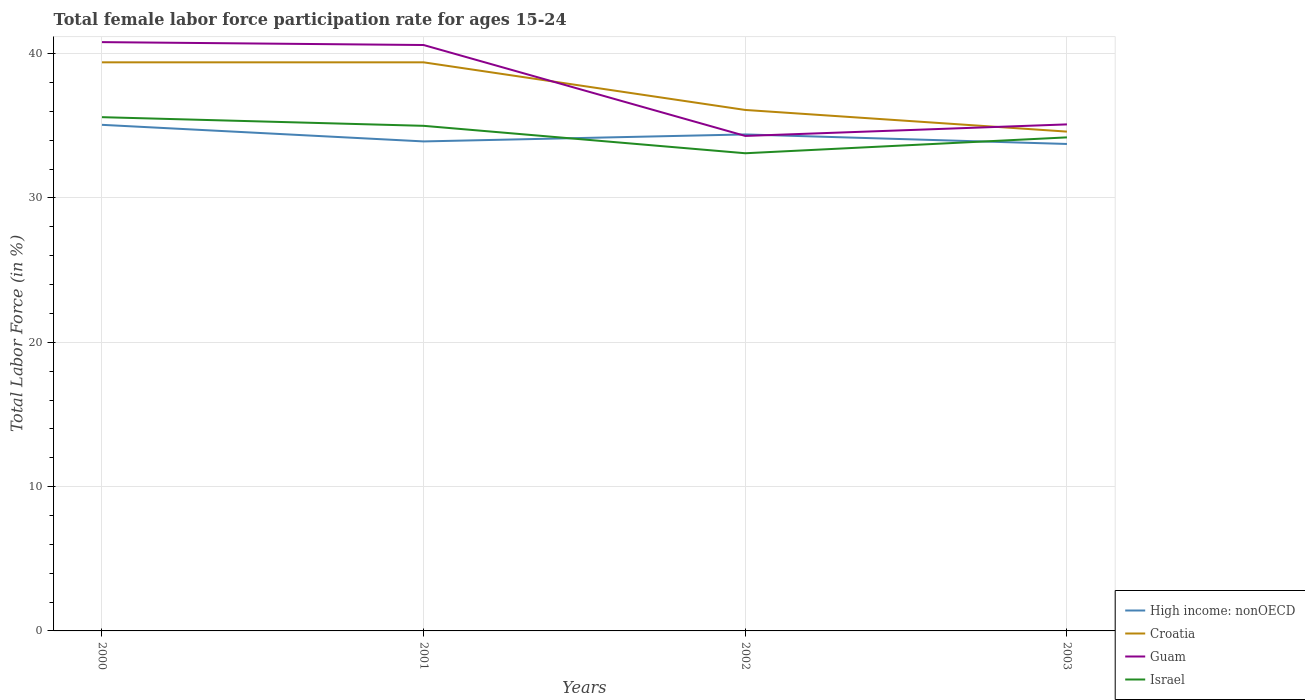How many different coloured lines are there?
Your answer should be compact. 4. Does the line corresponding to Guam intersect with the line corresponding to High income: nonOECD?
Your answer should be compact. Yes. Across all years, what is the maximum female labor force participation rate in Guam?
Your response must be concise. 34.3. In which year was the female labor force participation rate in Israel maximum?
Provide a short and direct response. 2002. What is the difference between the highest and the second highest female labor force participation rate in Croatia?
Your response must be concise. 4.8. What is the difference between the highest and the lowest female labor force participation rate in Croatia?
Your answer should be compact. 2. Are the values on the major ticks of Y-axis written in scientific E-notation?
Offer a terse response. No. Where does the legend appear in the graph?
Ensure brevity in your answer.  Bottom right. What is the title of the graph?
Offer a terse response. Total female labor force participation rate for ages 15-24. What is the Total Labor Force (in %) in High income: nonOECD in 2000?
Your response must be concise. 35.07. What is the Total Labor Force (in %) of Croatia in 2000?
Your answer should be compact. 39.4. What is the Total Labor Force (in %) of Guam in 2000?
Provide a succinct answer. 40.8. What is the Total Labor Force (in %) of Israel in 2000?
Keep it short and to the point. 35.6. What is the Total Labor Force (in %) of High income: nonOECD in 2001?
Provide a succinct answer. 33.92. What is the Total Labor Force (in %) of Croatia in 2001?
Keep it short and to the point. 39.4. What is the Total Labor Force (in %) in Guam in 2001?
Give a very brief answer. 40.6. What is the Total Labor Force (in %) in High income: nonOECD in 2002?
Your response must be concise. 34.4. What is the Total Labor Force (in %) in Croatia in 2002?
Make the answer very short. 36.1. What is the Total Labor Force (in %) in Guam in 2002?
Provide a short and direct response. 34.3. What is the Total Labor Force (in %) in Israel in 2002?
Make the answer very short. 33.1. What is the Total Labor Force (in %) of High income: nonOECD in 2003?
Keep it short and to the point. 33.74. What is the Total Labor Force (in %) in Croatia in 2003?
Your answer should be compact. 34.6. What is the Total Labor Force (in %) in Guam in 2003?
Ensure brevity in your answer.  35.1. What is the Total Labor Force (in %) in Israel in 2003?
Your answer should be compact. 34.2. Across all years, what is the maximum Total Labor Force (in %) in High income: nonOECD?
Offer a terse response. 35.07. Across all years, what is the maximum Total Labor Force (in %) in Croatia?
Your response must be concise. 39.4. Across all years, what is the maximum Total Labor Force (in %) of Guam?
Provide a short and direct response. 40.8. Across all years, what is the maximum Total Labor Force (in %) of Israel?
Provide a short and direct response. 35.6. Across all years, what is the minimum Total Labor Force (in %) of High income: nonOECD?
Your response must be concise. 33.74. Across all years, what is the minimum Total Labor Force (in %) in Croatia?
Offer a very short reply. 34.6. Across all years, what is the minimum Total Labor Force (in %) in Guam?
Your answer should be compact. 34.3. Across all years, what is the minimum Total Labor Force (in %) of Israel?
Offer a terse response. 33.1. What is the total Total Labor Force (in %) of High income: nonOECD in the graph?
Ensure brevity in your answer.  137.14. What is the total Total Labor Force (in %) of Croatia in the graph?
Make the answer very short. 149.5. What is the total Total Labor Force (in %) of Guam in the graph?
Ensure brevity in your answer.  150.8. What is the total Total Labor Force (in %) in Israel in the graph?
Provide a succinct answer. 137.9. What is the difference between the Total Labor Force (in %) of High income: nonOECD in 2000 and that in 2001?
Your answer should be compact. 1.15. What is the difference between the Total Labor Force (in %) of Croatia in 2000 and that in 2001?
Make the answer very short. 0. What is the difference between the Total Labor Force (in %) in Guam in 2000 and that in 2001?
Make the answer very short. 0.2. What is the difference between the Total Labor Force (in %) of Israel in 2000 and that in 2001?
Your answer should be very brief. 0.6. What is the difference between the Total Labor Force (in %) in High income: nonOECD in 2000 and that in 2002?
Make the answer very short. 0.67. What is the difference between the Total Labor Force (in %) of Guam in 2000 and that in 2002?
Provide a succinct answer. 6.5. What is the difference between the Total Labor Force (in %) in High income: nonOECD in 2000 and that in 2003?
Make the answer very short. 1.33. What is the difference between the Total Labor Force (in %) of Croatia in 2000 and that in 2003?
Give a very brief answer. 4.8. What is the difference between the Total Labor Force (in %) in Guam in 2000 and that in 2003?
Provide a short and direct response. 5.7. What is the difference between the Total Labor Force (in %) in High income: nonOECD in 2001 and that in 2002?
Your answer should be very brief. -0.48. What is the difference between the Total Labor Force (in %) of Croatia in 2001 and that in 2002?
Ensure brevity in your answer.  3.3. What is the difference between the Total Labor Force (in %) of Guam in 2001 and that in 2002?
Your answer should be very brief. 6.3. What is the difference between the Total Labor Force (in %) in High income: nonOECD in 2001 and that in 2003?
Your answer should be very brief. 0.18. What is the difference between the Total Labor Force (in %) in Croatia in 2001 and that in 2003?
Ensure brevity in your answer.  4.8. What is the difference between the Total Labor Force (in %) in Israel in 2001 and that in 2003?
Make the answer very short. 0.8. What is the difference between the Total Labor Force (in %) in High income: nonOECD in 2002 and that in 2003?
Keep it short and to the point. 0.66. What is the difference between the Total Labor Force (in %) in Croatia in 2002 and that in 2003?
Give a very brief answer. 1.5. What is the difference between the Total Labor Force (in %) of Guam in 2002 and that in 2003?
Keep it short and to the point. -0.8. What is the difference between the Total Labor Force (in %) of Israel in 2002 and that in 2003?
Keep it short and to the point. -1.1. What is the difference between the Total Labor Force (in %) in High income: nonOECD in 2000 and the Total Labor Force (in %) in Croatia in 2001?
Provide a succinct answer. -4.33. What is the difference between the Total Labor Force (in %) in High income: nonOECD in 2000 and the Total Labor Force (in %) in Guam in 2001?
Make the answer very short. -5.53. What is the difference between the Total Labor Force (in %) in High income: nonOECD in 2000 and the Total Labor Force (in %) in Israel in 2001?
Offer a very short reply. 0.07. What is the difference between the Total Labor Force (in %) of Croatia in 2000 and the Total Labor Force (in %) of Guam in 2001?
Provide a succinct answer. -1.2. What is the difference between the Total Labor Force (in %) of Guam in 2000 and the Total Labor Force (in %) of Israel in 2001?
Your answer should be very brief. 5.8. What is the difference between the Total Labor Force (in %) in High income: nonOECD in 2000 and the Total Labor Force (in %) in Croatia in 2002?
Provide a succinct answer. -1.03. What is the difference between the Total Labor Force (in %) of High income: nonOECD in 2000 and the Total Labor Force (in %) of Guam in 2002?
Your response must be concise. 0.77. What is the difference between the Total Labor Force (in %) of High income: nonOECD in 2000 and the Total Labor Force (in %) of Israel in 2002?
Give a very brief answer. 1.97. What is the difference between the Total Labor Force (in %) of Croatia in 2000 and the Total Labor Force (in %) of Guam in 2002?
Make the answer very short. 5.1. What is the difference between the Total Labor Force (in %) in Guam in 2000 and the Total Labor Force (in %) in Israel in 2002?
Provide a succinct answer. 7.7. What is the difference between the Total Labor Force (in %) of High income: nonOECD in 2000 and the Total Labor Force (in %) of Croatia in 2003?
Your answer should be very brief. 0.47. What is the difference between the Total Labor Force (in %) in High income: nonOECD in 2000 and the Total Labor Force (in %) in Guam in 2003?
Give a very brief answer. -0.03. What is the difference between the Total Labor Force (in %) in High income: nonOECD in 2000 and the Total Labor Force (in %) in Israel in 2003?
Make the answer very short. 0.87. What is the difference between the Total Labor Force (in %) in Guam in 2000 and the Total Labor Force (in %) in Israel in 2003?
Keep it short and to the point. 6.6. What is the difference between the Total Labor Force (in %) in High income: nonOECD in 2001 and the Total Labor Force (in %) in Croatia in 2002?
Your answer should be compact. -2.18. What is the difference between the Total Labor Force (in %) of High income: nonOECD in 2001 and the Total Labor Force (in %) of Guam in 2002?
Give a very brief answer. -0.38. What is the difference between the Total Labor Force (in %) in High income: nonOECD in 2001 and the Total Labor Force (in %) in Israel in 2002?
Make the answer very short. 0.82. What is the difference between the Total Labor Force (in %) of Croatia in 2001 and the Total Labor Force (in %) of Guam in 2002?
Offer a terse response. 5.1. What is the difference between the Total Labor Force (in %) in Guam in 2001 and the Total Labor Force (in %) in Israel in 2002?
Ensure brevity in your answer.  7.5. What is the difference between the Total Labor Force (in %) in High income: nonOECD in 2001 and the Total Labor Force (in %) in Croatia in 2003?
Provide a short and direct response. -0.68. What is the difference between the Total Labor Force (in %) in High income: nonOECD in 2001 and the Total Labor Force (in %) in Guam in 2003?
Offer a terse response. -1.18. What is the difference between the Total Labor Force (in %) in High income: nonOECD in 2001 and the Total Labor Force (in %) in Israel in 2003?
Your response must be concise. -0.28. What is the difference between the Total Labor Force (in %) of Croatia in 2001 and the Total Labor Force (in %) of Israel in 2003?
Ensure brevity in your answer.  5.2. What is the difference between the Total Labor Force (in %) in Guam in 2001 and the Total Labor Force (in %) in Israel in 2003?
Offer a terse response. 6.4. What is the difference between the Total Labor Force (in %) in High income: nonOECD in 2002 and the Total Labor Force (in %) in Croatia in 2003?
Offer a terse response. -0.2. What is the difference between the Total Labor Force (in %) in High income: nonOECD in 2002 and the Total Labor Force (in %) in Guam in 2003?
Provide a short and direct response. -0.7. What is the difference between the Total Labor Force (in %) in High income: nonOECD in 2002 and the Total Labor Force (in %) in Israel in 2003?
Your answer should be very brief. 0.2. What is the difference between the Total Labor Force (in %) of Croatia in 2002 and the Total Labor Force (in %) of Guam in 2003?
Provide a succinct answer. 1. What is the difference between the Total Labor Force (in %) in Croatia in 2002 and the Total Labor Force (in %) in Israel in 2003?
Keep it short and to the point. 1.9. What is the difference between the Total Labor Force (in %) of Guam in 2002 and the Total Labor Force (in %) of Israel in 2003?
Provide a short and direct response. 0.1. What is the average Total Labor Force (in %) in High income: nonOECD per year?
Give a very brief answer. 34.28. What is the average Total Labor Force (in %) of Croatia per year?
Give a very brief answer. 37.38. What is the average Total Labor Force (in %) in Guam per year?
Provide a succinct answer. 37.7. What is the average Total Labor Force (in %) of Israel per year?
Your response must be concise. 34.48. In the year 2000, what is the difference between the Total Labor Force (in %) in High income: nonOECD and Total Labor Force (in %) in Croatia?
Make the answer very short. -4.33. In the year 2000, what is the difference between the Total Labor Force (in %) in High income: nonOECD and Total Labor Force (in %) in Guam?
Your answer should be very brief. -5.73. In the year 2000, what is the difference between the Total Labor Force (in %) in High income: nonOECD and Total Labor Force (in %) in Israel?
Provide a short and direct response. -0.53. In the year 2000, what is the difference between the Total Labor Force (in %) in Guam and Total Labor Force (in %) in Israel?
Offer a very short reply. 5.2. In the year 2001, what is the difference between the Total Labor Force (in %) of High income: nonOECD and Total Labor Force (in %) of Croatia?
Ensure brevity in your answer.  -5.48. In the year 2001, what is the difference between the Total Labor Force (in %) of High income: nonOECD and Total Labor Force (in %) of Guam?
Make the answer very short. -6.68. In the year 2001, what is the difference between the Total Labor Force (in %) in High income: nonOECD and Total Labor Force (in %) in Israel?
Provide a short and direct response. -1.08. In the year 2001, what is the difference between the Total Labor Force (in %) of Croatia and Total Labor Force (in %) of Israel?
Offer a very short reply. 4.4. In the year 2001, what is the difference between the Total Labor Force (in %) in Guam and Total Labor Force (in %) in Israel?
Provide a short and direct response. 5.6. In the year 2002, what is the difference between the Total Labor Force (in %) of High income: nonOECD and Total Labor Force (in %) of Croatia?
Make the answer very short. -1.7. In the year 2002, what is the difference between the Total Labor Force (in %) in High income: nonOECD and Total Labor Force (in %) in Guam?
Ensure brevity in your answer.  0.1. In the year 2002, what is the difference between the Total Labor Force (in %) of High income: nonOECD and Total Labor Force (in %) of Israel?
Your response must be concise. 1.3. In the year 2002, what is the difference between the Total Labor Force (in %) of Croatia and Total Labor Force (in %) of Israel?
Your response must be concise. 3. In the year 2002, what is the difference between the Total Labor Force (in %) in Guam and Total Labor Force (in %) in Israel?
Keep it short and to the point. 1.2. In the year 2003, what is the difference between the Total Labor Force (in %) of High income: nonOECD and Total Labor Force (in %) of Croatia?
Make the answer very short. -0.86. In the year 2003, what is the difference between the Total Labor Force (in %) in High income: nonOECD and Total Labor Force (in %) in Guam?
Offer a very short reply. -1.36. In the year 2003, what is the difference between the Total Labor Force (in %) of High income: nonOECD and Total Labor Force (in %) of Israel?
Provide a short and direct response. -0.46. In the year 2003, what is the difference between the Total Labor Force (in %) of Guam and Total Labor Force (in %) of Israel?
Make the answer very short. 0.9. What is the ratio of the Total Labor Force (in %) in High income: nonOECD in 2000 to that in 2001?
Ensure brevity in your answer.  1.03. What is the ratio of the Total Labor Force (in %) in Croatia in 2000 to that in 2001?
Your answer should be very brief. 1. What is the ratio of the Total Labor Force (in %) of Guam in 2000 to that in 2001?
Your response must be concise. 1. What is the ratio of the Total Labor Force (in %) of Israel in 2000 to that in 2001?
Your response must be concise. 1.02. What is the ratio of the Total Labor Force (in %) of High income: nonOECD in 2000 to that in 2002?
Provide a succinct answer. 1.02. What is the ratio of the Total Labor Force (in %) of Croatia in 2000 to that in 2002?
Your answer should be compact. 1.09. What is the ratio of the Total Labor Force (in %) in Guam in 2000 to that in 2002?
Give a very brief answer. 1.19. What is the ratio of the Total Labor Force (in %) in Israel in 2000 to that in 2002?
Keep it short and to the point. 1.08. What is the ratio of the Total Labor Force (in %) of High income: nonOECD in 2000 to that in 2003?
Provide a succinct answer. 1.04. What is the ratio of the Total Labor Force (in %) of Croatia in 2000 to that in 2003?
Ensure brevity in your answer.  1.14. What is the ratio of the Total Labor Force (in %) of Guam in 2000 to that in 2003?
Give a very brief answer. 1.16. What is the ratio of the Total Labor Force (in %) of Israel in 2000 to that in 2003?
Your response must be concise. 1.04. What is the ratio of the Total Labor Force (in %) in High income: nonOECD in 2001 to that in 2002?
Give a very brief answer. 0.99. What is the ratio of the Total Labor Force (in %) in Croatia in 2001 to that in 2002?
Offer a terse response. 1.09. What is the ratio of the Total Labor Force (in %) in Guam in 2001 to that in 2002?
Ensure brevity in your answer.  1.18. What is the ratio of the Total Labor Force (in %) of Israel in 2001 to that in 2002?
Keep it short and to the point. 1.06. What is the ratio of the Total Labor Force (in %) in Croatia in 2001 to that in 2003?
Give a very brief answer. 1.14. What is the ratio of the Total Labor Force (in %) of Guam in 2001 to that in 2003?
Your response must be concise. 1.16. What is the ratio of the Total Labor Force (in %) in Israel in 2001 to that in 2003?
Make the answer very short. 1.02. What is the ratio of the Total Labor Force (in %) in High income: nonOECD in 2002 to that in 2003?
Keep it short and to the point. 1.02. What is the ratio of the Total Labor Force (in %) of Croatia in 2002 to that in 2003?
Your answer should be compact. 1.04. What is the ratio of the Total Labor Force (in %) of Guam in 2002 to that in 2003?
Offer a terse response. 0.98. What is the ratio of the Total Labor Force (in %) of Israel in 2002 to that in 2003?
Your response must be concise. 0.97. What is the difference between the highest and the second highest Total Labor Force (in %) of High income: nonOECD?
Offer a terse response. 0.67. What is the difference between the highest and the second highest Total Labor Force (in %) in Croatia?
Ensure brevity in your answer.  0. What is the difference between the highest and the second highest Total Labor Force (in %) in Guam?
Offer a terse response. 0.2. What is the difference between the highest and the lowest Total Labor Force (in %) in High income: nonOECD?
Your answer should be very brief. 1.33. What is the difference between the highest and the lowest Total Labor Force (in %) in Croatia?
Your answer should be very brief. 4.8. What is the difference between the highest and the lowest Total Labor Force (in %) in Guam?
Make the answer very short. 6.5. 